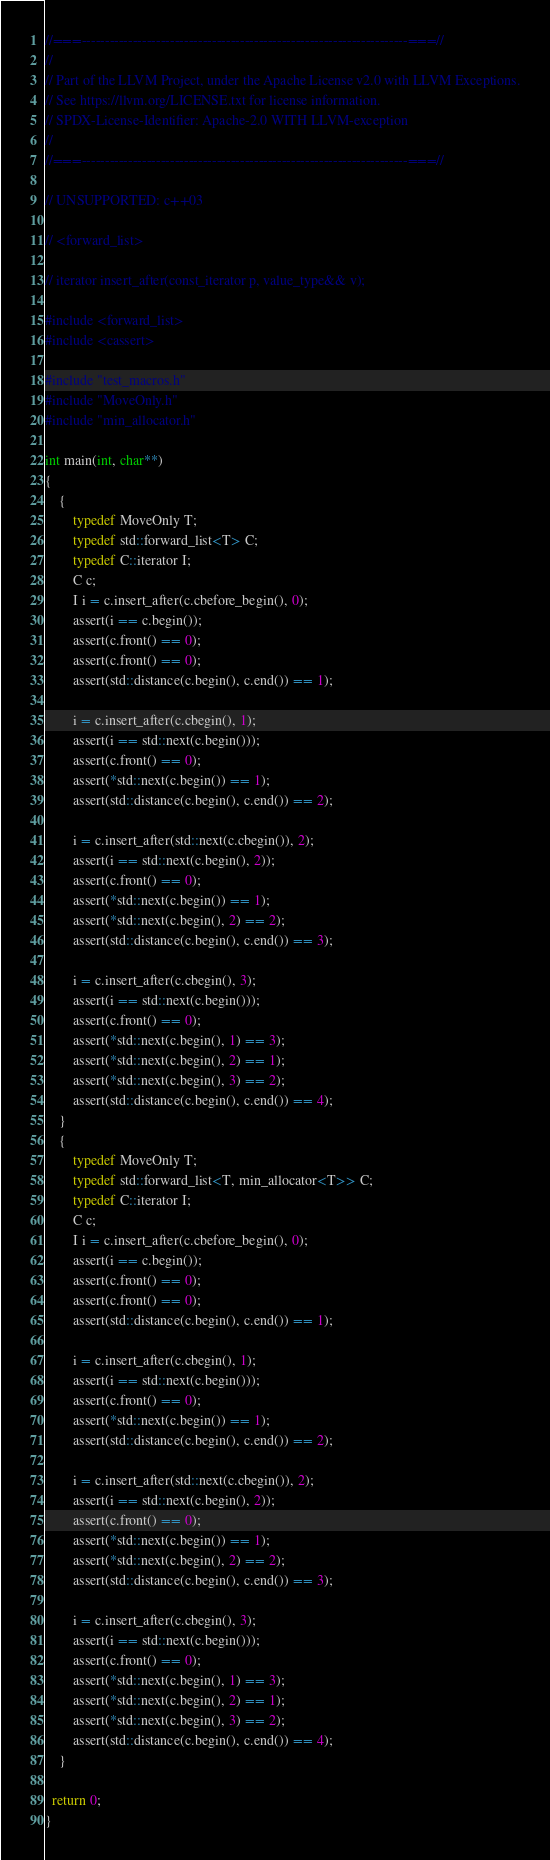Convert code to text. <code><loc_0><loc_0><loc_500><loc_500><_C++_>//===----------------------------------------------------------------------===//
//
// Part of the LLVM Project, under the Apache License v2.0 with LLVM Exceptions.
// See https://llvm.org/LICENSE.txt for license information.
// SPDX-License-Identifier: Apache-2.0 WITH LLVM-exception
//
//===----------------------------------------------------------------------===//

// UNSUPPORTED: c++03

// <forward_list>

// iterator insert_after(const_iterator p, value_type&& v);

#include <forward_list>
#include <cassert>

#include "test_macros.h"
#include "MoveOnly.h"
#include "min_allocator.h"

int main(int, char**)
{
    {
        typedef MoveOnly T;
        typedef std::forward_list<T> C;
        typedef C::iterator I;
        C c;
        I i = c.insert_after(c.cbefore_begin(), 0);
        assert(i == c.begin());
        assert(c.front() == 0);
        assert(c.front() == 0);
        assert(std::distance(c.begin(), c.end()) == 1);

        i = c.insert_after(c.cbegin(), 1);
        assert(i == std::next(c.begin()));
        assert(c.front() == 0);
        assert(*std::next(c.begin()) == 1);
        assert(std::distance(c.begin(), c.end()) == 2);

        i = c.insert_after(std::next(c.cbegin()), 2);
        assert(i == std::next(c.begin(), 2));
        assert(c.front() == 0);
        assert(*std::next(c.begin()) == 1);
        assert(*std::next(c.begin(), 2) == 2);
        assert(std::distance(c.begin(), c.end()) == 3);

        i = c.insert_after(c.cbegin(), 3);
        assert(i == std::next(c.begin()));
        assert(c.front() == 0);
        assert(*std::next(c.begin(), 1) == 3);
        assert(*std::next(c.begin(), 2) == 1);
        assert(*std::next(c.begin(), 3) == 2);
        assert(std::distance(c.begin(), c.end()) == 4);
    }
    {
        typedef MoveOnly T;
        typedef std::forward_list<T, min_allocator<T>> C;
        typedef C::iterator I;
        C c;
        I i = c.insert_after(c.cbefore_begin(), 0);
        assert(i == c.begin());
        assert(c.front() == 0);
        assert(c.front() == 0);
        assert(std::distance(c.begin(), c.end()) == 1);

        i = c.insert_after(c.cbegin(), 1);
        assert(i == std::next(c.begin()));
        assert(c.front() == 0);
        assert(*std::next(c.begin()) == 1);
        assert(std::distance(c.begin(), c.end()) == 2);

        i = c.insert_after(std::next(c.cbegin()), 2);
        assert(i == std::next(c.begin(), 2));
        assert(c.front() == 0);
        assert(*std::next(c.begin()) == 1);
        assert(*std::next(c.begin(), 2) == 2);
        assert(std::distance(c.begin(), c.end()) == 3);

        i = c.insert_after(c.cbegin(), 3);
        assert(i == std::next(c.begin()));
        assert(c.front() == 0);
        assert(*std::next(c.begin(), 1) == 3);
        assert(*std::next(c.begin(), 2) == 1);
        assert(*std::next(c.begin(), 3) == 2);
        assert(std::distance(c.begin(), c.end()) == 4);
    }

  return 0;
}
</code> 